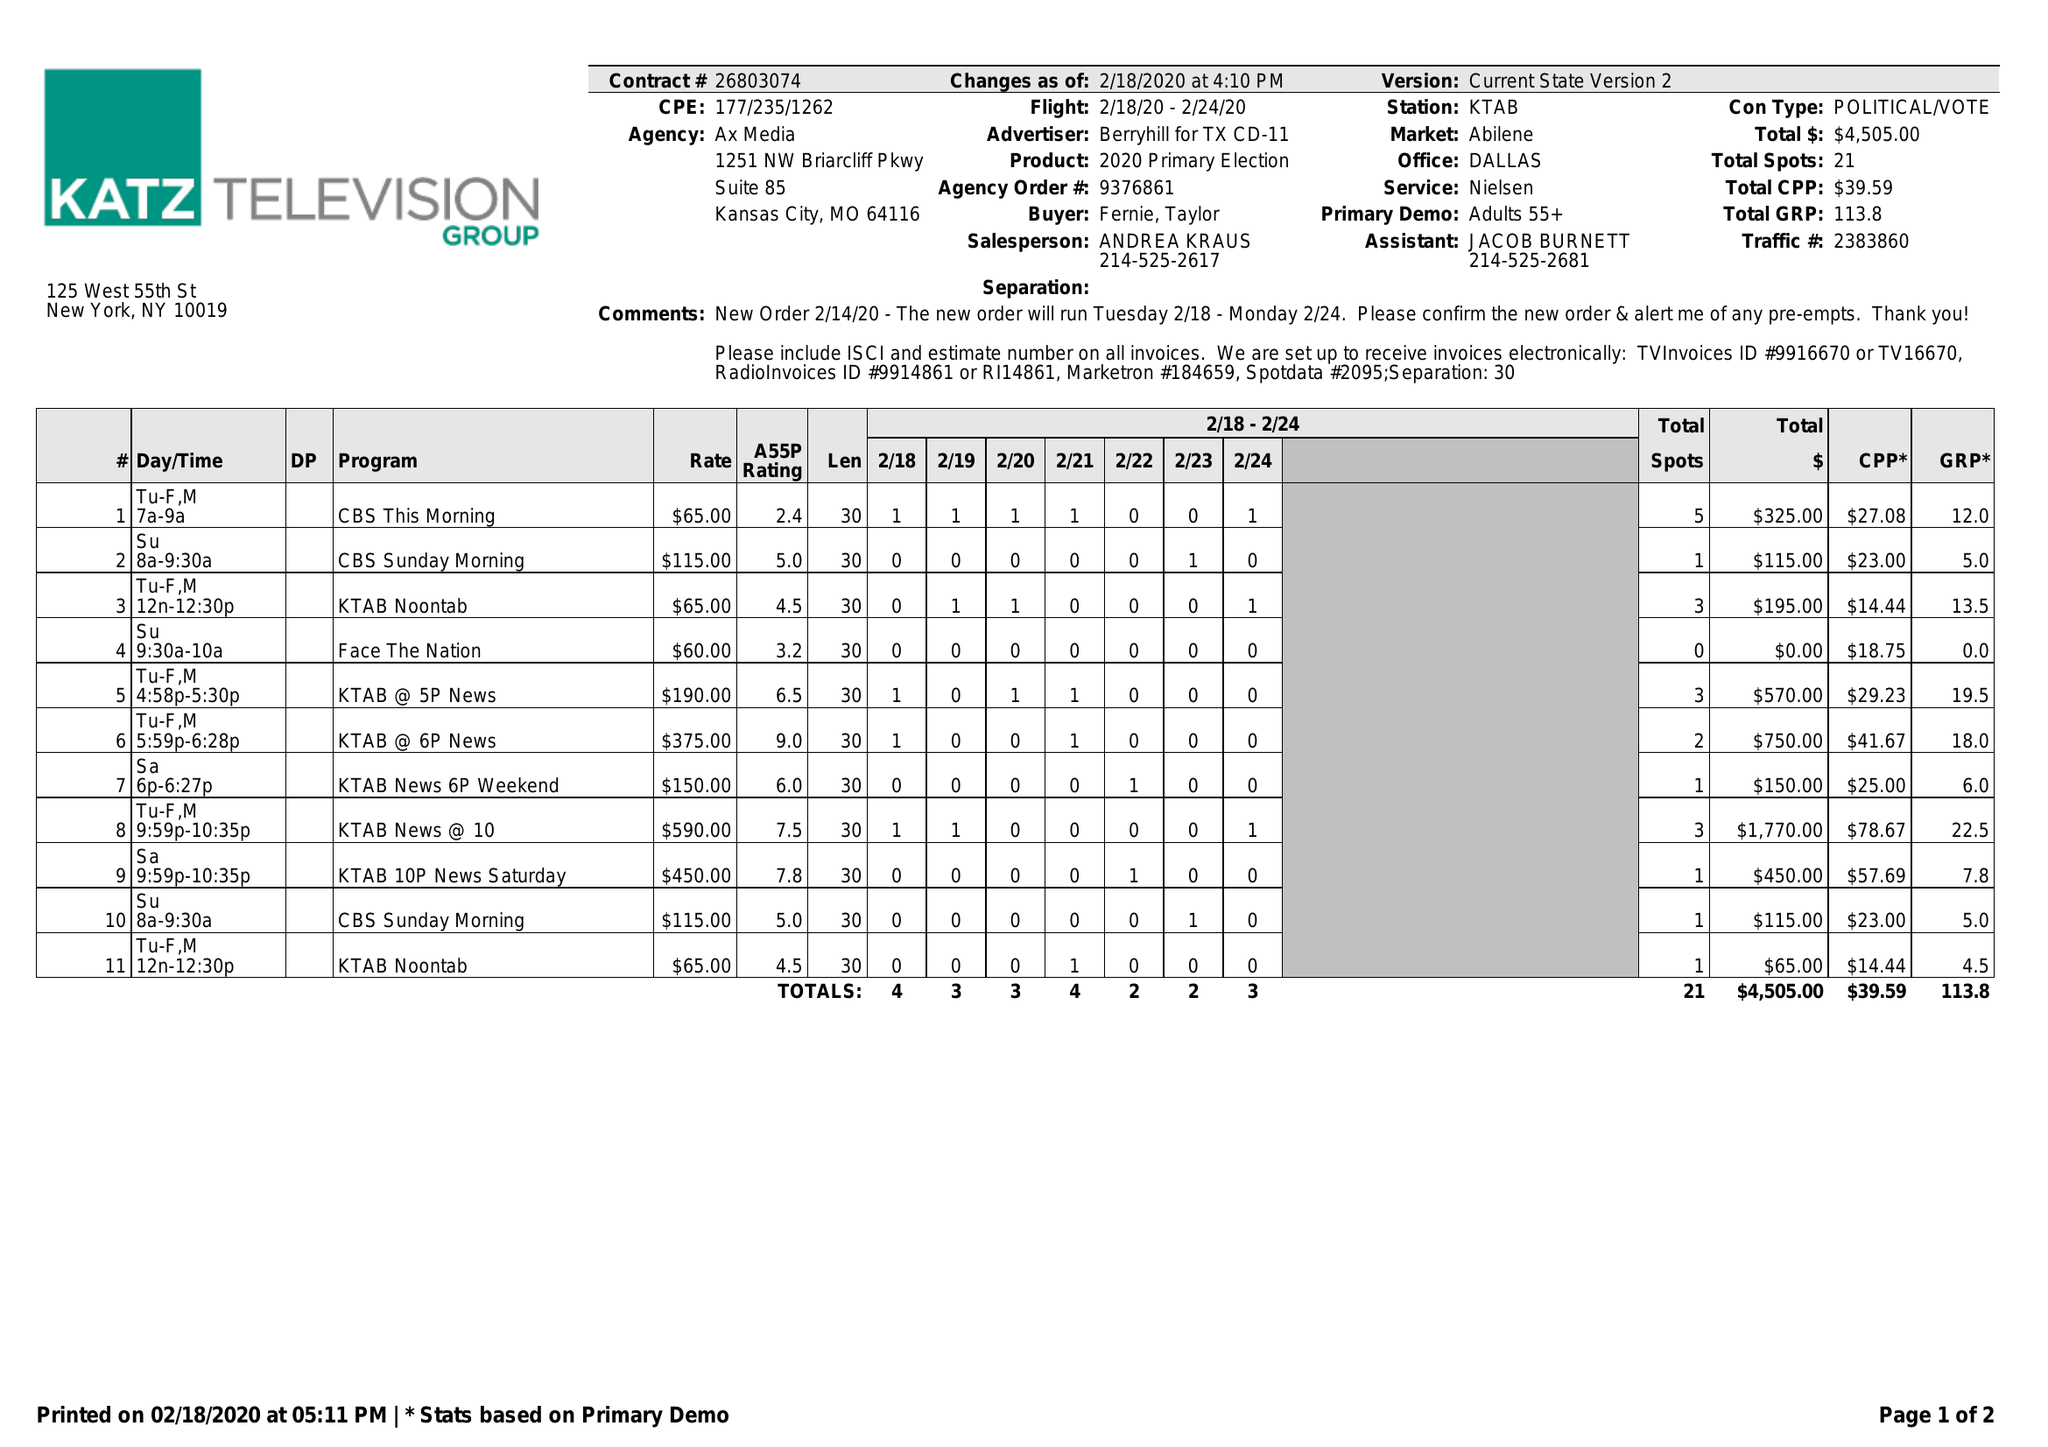What is the value for the gross_amount?
Answer the question using a single word or phrase. 4505.00 